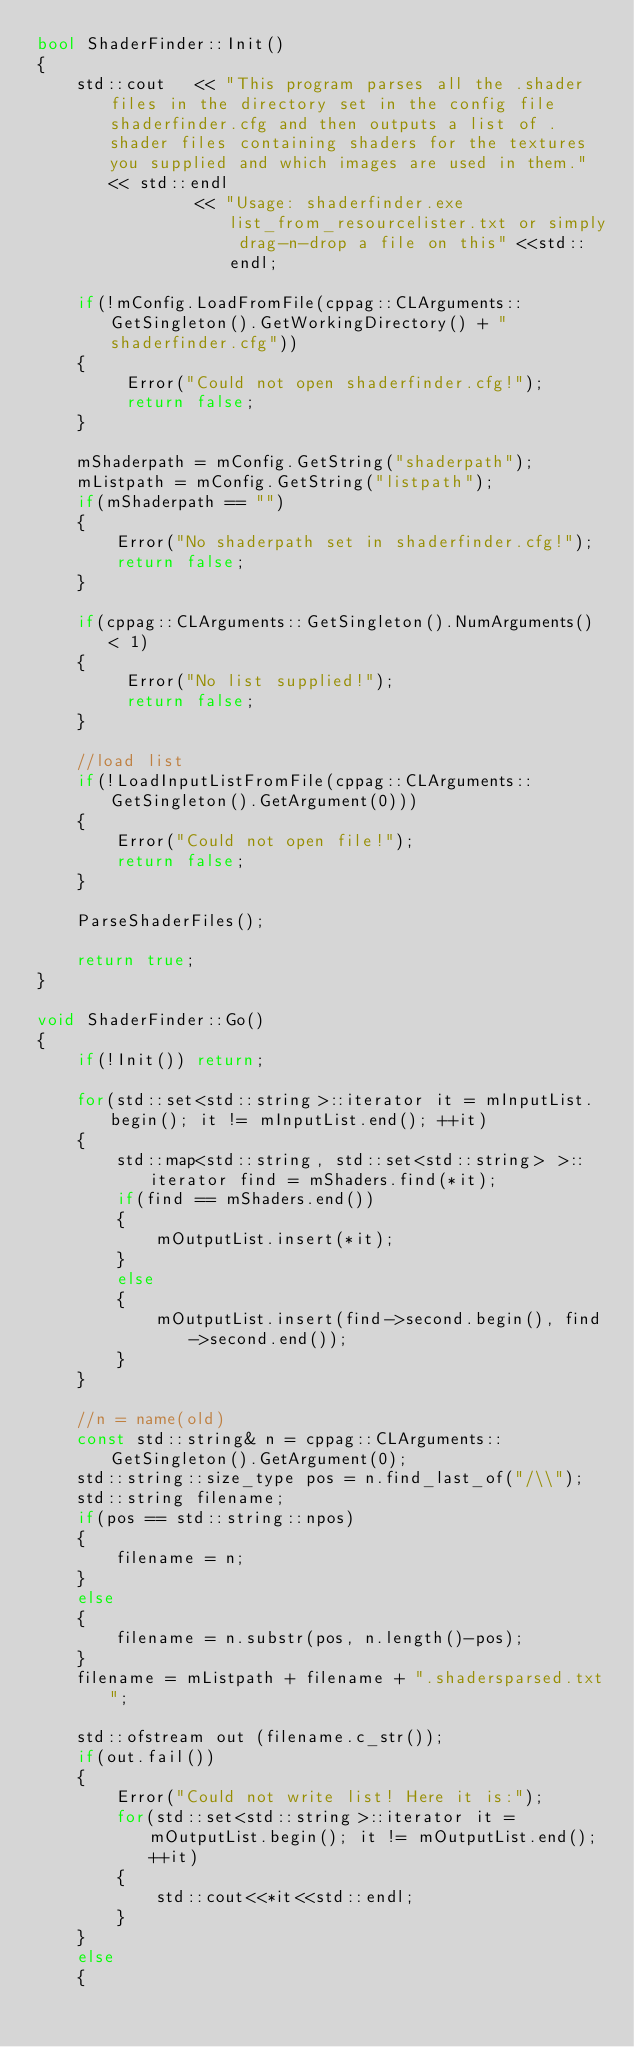Convert code to text. <code><loc_0><loc_0><loc_500><loc_500><_C++_>bool ShaderFinder::Init()
{
    std::cout   << "This program parses all the .shader files in the directory set in the config file shaderfinder.cfg and then outputs a list of .shader files containing shaders for the textures you supplied and which images are used in them." << std::endl
                << "Usage: shaderfinder.exe list_from_resourcelister.txt or simply drag-n-drop a file on this" <<std::endl;

    if(!mConfig.LoadFromFile(cppag::CLArguments::GetSingleton().GetWorkingDirectory() + "shaderfinder.cfg"))
    {
         Error("Could not open shaderfinder.cfg!");
         return false;
    }

    mShaderpath = mConfig.GetString("shaderpath");
    mListpath = mConfig.GetString("listpath");
    if(mShaderpath == "")
    {
        Error("No shaderpath set in shaderfinder.cfg!");
        return false;
    }

    if(cppag::CLArguments::GetSingleton().NumArguments() < 1)
    {
         Error("No list supplied!");
         return false;
    }

    //load list
    if(!LoadInputListFromFile(cppag::CLArguments::GetSingleton().GetArgument(0)))
    {
        Error("Could not open file!");
        return false;
    }

    ParseShaderFiles();

    return true;
}

void ShaderFinder::Go()
{
    if(!Init()) return;

    for(std::set<std::string>::iterator it = mInputList.begin(); it != mInputList.end(); ++it)
    {
        std::map<std::string, std::set<std::string> >::iterator find = mShaders.find(*it);
        if(find == mShaders.end())
        {
            mOutputList.insert(*it);
        }
        else
        {
            mOutputList.insert(find->second.begin(), find->second.end());
        }
    }

    //n = name(old)
    const std::string& n = cppag::CLArguments::GetSingleton().GetArgument(0);
    std::string::size_type pos = n.find_last_of("/\\");
    std::string filename;
    if(pos == std::string::npos)
    {
        filename = n;
    }
    else
    {
        filename = n.substr(pos, n.length()-pos);
    }
    filename = mListpath + filename + ".shadersparsed.txt";

    std::ofstream out (filename.c_str());
    if(out.fail())
    {
        Error("Could not write list! Here it is:");
        for(std::set<std::string>::iterator it = mOutputList.begin(); it != mOutputList.end(); ++it)
        {
            std::cout<<*it<<std::endl;
        }
    }
    else
    {</code> 